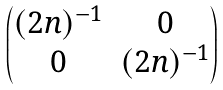Convert formula to latex. <formula><loc_0><loc_0><loc_500><loc_500>\begin{pmatrix} ( 2 n ) ^ { - 1 } & 0 \\ 0 & ( 2 n ) ^ { - 1 } \end{pmatrix}</formula> 